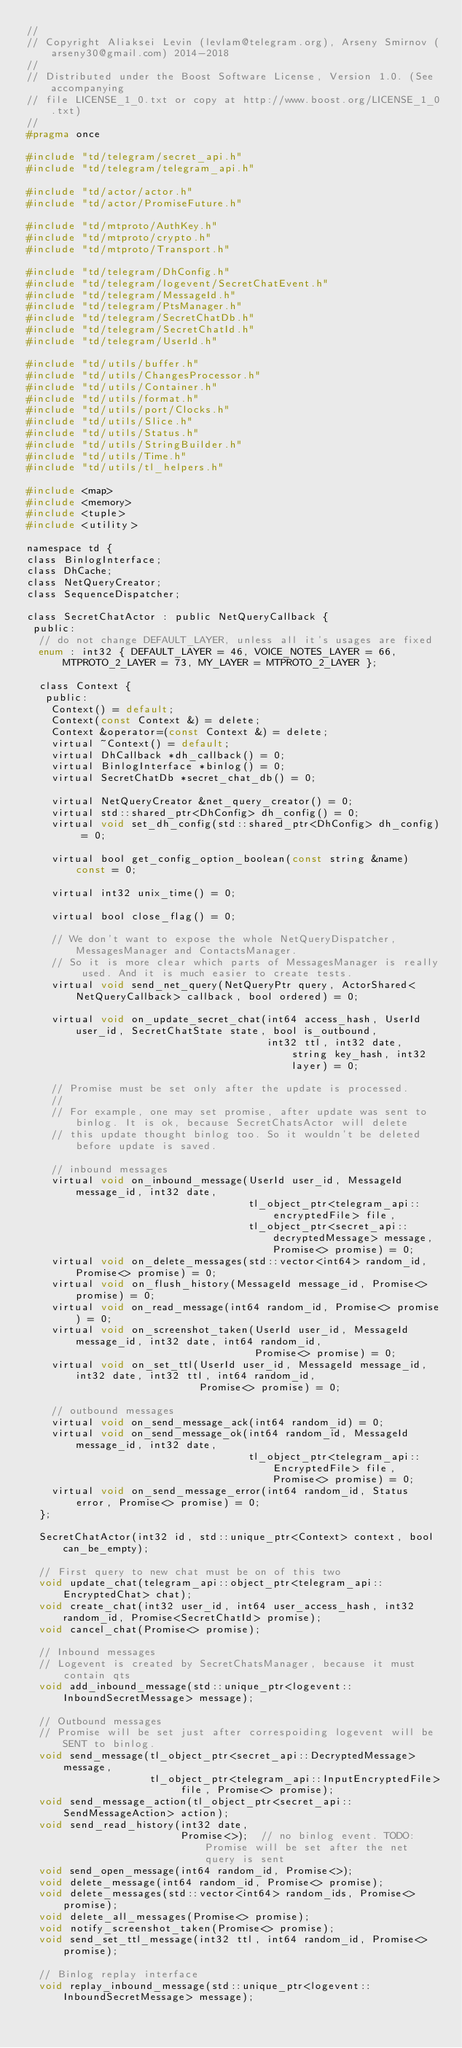Convert code to text. <code><loc_0><loc_0><loc_500><loc_500><_C_>//
// Copyright Aliaksei Levin (levlam@telegram.org), Arseny Smirnov (arseny30@gmail.com) 2014-2018
//
// Distributed under the Boost Software License, Version 1.0. (See accompanying
// file LICENSE_1_0.txt or copy at http://www.boost.org/LICENSE_1_0.txt)
//
#pragma once

#include "td/telegram/secret_api.h"
#include "td/telegram/telegram_api.h"

#include "td/actor/actor.h"
#include "td/actor/PromiseFuture.h"

#include "td/mtproto/AuthKey.h"
#include "td/mtproto/crypto.h"
#include "td/mtproto/Transport.h"

#include "td/telegram/DhConfig.h"
#include "td/telegram/logevent/SecretChatEvent.h"
#include "td/telegram/MessageId.h"
#include "td/telegram/PtsManager.h"
#include "td/telegram/SecretChatDb.h"
#include "td/telegram/SecretChatId.h"
#include "td/telegram/UserId.h"

#include "td/utils/buffer.h"
#include "td/utils/ChangesProcessor.h"
#include "td/utils/Container.h"
#include "td/utils/format.h"
#include "td/utils/port/Clocks.h"
#include "td/utils/Slice.h"
#include "td/utils/Status.h"
#include "td/utils/StringBuilder.h"
#include "td/utils/Time.h"
#include "td/utils/tl_helpers.h"

#include <map>
#include <memory>
#include <tuple>
#include <utility>

namespace td {
class BinlogInterface;
class DhCache;
class NetQueryCreator;
class SequenceDispatcher;

class SecretChatActor : public NetQueryCallback {
 public:
  // do not change DEFAULT_LAYER, unless all it's usages are fixed
  enum : int32 { DEFAULT_LAYER = 46, VOICE_NOTES_LAYER = 66, MTPROTO_2_LAYER = 73, MY_LAYER = MTPROTO_2_LAYER };

  class Context {
   public:
    Context() = default;
    Context(const Context &) = delete;
    Context &operator=(const Context &) = delete;
    virtual ~Context() = default;
    virtual DhCallback *dh_callback() = 0;
    virtual BinlogInterface *binlog() = 0;
    virtual SecretChatDb *secret_chat_db() = 0;

    virtual NetQueryCreator &net_query_creator() = 0;
    virtual std::shared_ptr<DhConfig> dh_config() = 0;
    virtual void set_dh_config(std::shared_ptr<DhConfig> dh_config) = 0;

    virtual bool get_config_option_boolean(const string &name) const = 0;

    virtual int32 unix_time() = 0;

    virtual bool close_flag() = 0;

    // We don't want to expose the whole NetQueryDispatcher, MessagesManager and ContactsManager.
    // So it is more clear which parts of MessagesManager is really used. And it is much easier to create tests.
    virtual void send_net_query(NetQueryPtr query, ActorShared<NetQueryCallback> callback, bool ordered) = 0;

    virtual void on_update_secret_chat(int64 access_hash, UserId user_id, SecretChatState state, bool is_outbound,
                                       int32 ttl, int32 date, string key_hash, int32 layer) = 0;

    // Promise must be set only after the update is processed.
    //
    // For example, one may set promise, after update was sent to binlog. It is ok, because SecretChatsActor will delete
    // this update thought binlog too. So it wouldn't be deleted before update is saved.

    // inbound messages
    virtual void on_inbound_message(UserId user_id, MessageId message_id, int32 date,
                                    tl_object_ptr<telegram_api::encryptedFile> file,
                                    tl_object_ptr<secret_api::decryptedMessage> message, Promise<> promise) = 0;
    virtual void on_delete_messages(std::vector<int64> random_id, Promise<> promise) = 0;
    virtual void on_flush_history(MessageId message_id, Promise<> promise) = 0;
    virtual void on_read_message(int64 random_id, Promise<> promise) = 0;
    virtual void on_screenshot_taken(UserId user_id, MessageId message_id, int32 date, int64 random_id,
                                     Promise<> promise) = 0;
    virtual void on_set_ttl(UserId user_id, MessageId message_id, int32 date, int32 ttl, int64 random_id,
                            Promise<> promise) = 0;

    // outbound messages
    virtual void on_send_message_ack(int64 random_id) = 0;
    virtual void on_send_message_ok(int64 random_id, MessageId message_id, int32 date,
                                    tl_object_ptr<telegram_api::EncryptedFile> file, Promise<> promise) = 0;
    virtual void on_send_message_error(int64 random_id, Status error, Promise<> promise) = 0;
  };

  SecretChatActor(int32 id, std::unique_ptr<Context> context, bool can_be_empty);

  // First query to new chat must be on of this two
  void update_chat(telegram_api::object_ptr<telegram_api::EncryptedChat> chat);
  void create_chat(int32 user_id, int64 user_access_hash, int32 random_id, Promise<SecretChatId> promise);
  void cancel_chat(Promise<> promise);

  // Inbound messages
  // Logevent is created by SecretChatsManager, because it must contain qts
  void add_inbound_message(std::unique_ptr<logevent::InboundSecretMessage> message);

  // Outbound messages
  // Promise will be set just after correspoiding logevent will be SENT to binlog.
  void send_message(tl_object_ptr<secret_api::DecryptedMessage> message,
                    tl_object_ptr<telegram_api::InputEncryptedFile> file, Promise<> promise);
  void send_message_action(tl_object_ptr<secret_api::SendMessageAction> action);
  void send_read_history(int32 date,
                         Promise<>);  // no binlog event. TODO: Promise will be set after the net query is sent
  void send_open_message(int64 random_id, Promise<>);
  void delete_message(int64 random_id, Promise<> promise);
  void delete_messages(std::vector<int64> random_ids, Promise<> promise);
  void delete_all_messages(Promise<> promise);
  void notify_screenshot_taken(Promise<> promise);
  void send_set_ttl_message(int32 ttl, int64 random_id, Promise<> promise);

  // Binlog replay interface
  void replay_inbound_message(std::unique_ptr<logevent::InboundSecretMessage> message);</code> 